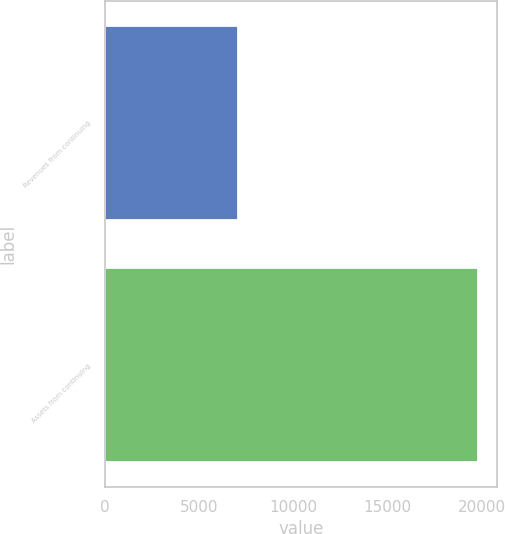Convert chart to OTSL. <chart><loc_0><loc_0><loc_500><loc_500><bar_chart><fcel>Revenues from continuing<fcel>Assets from continuing<nl><fcel>7072.7<fcel>19813.4<nl></chart> 